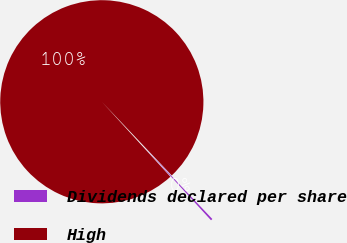Convert chart to OTSL. <chart><loc_0><loc_0><loc_500><loc_500><pie_chart><fcel>Dividends declared per share<fcel>High<nl><fcel>0.29%<fcel>99.71%<nl></chart> 